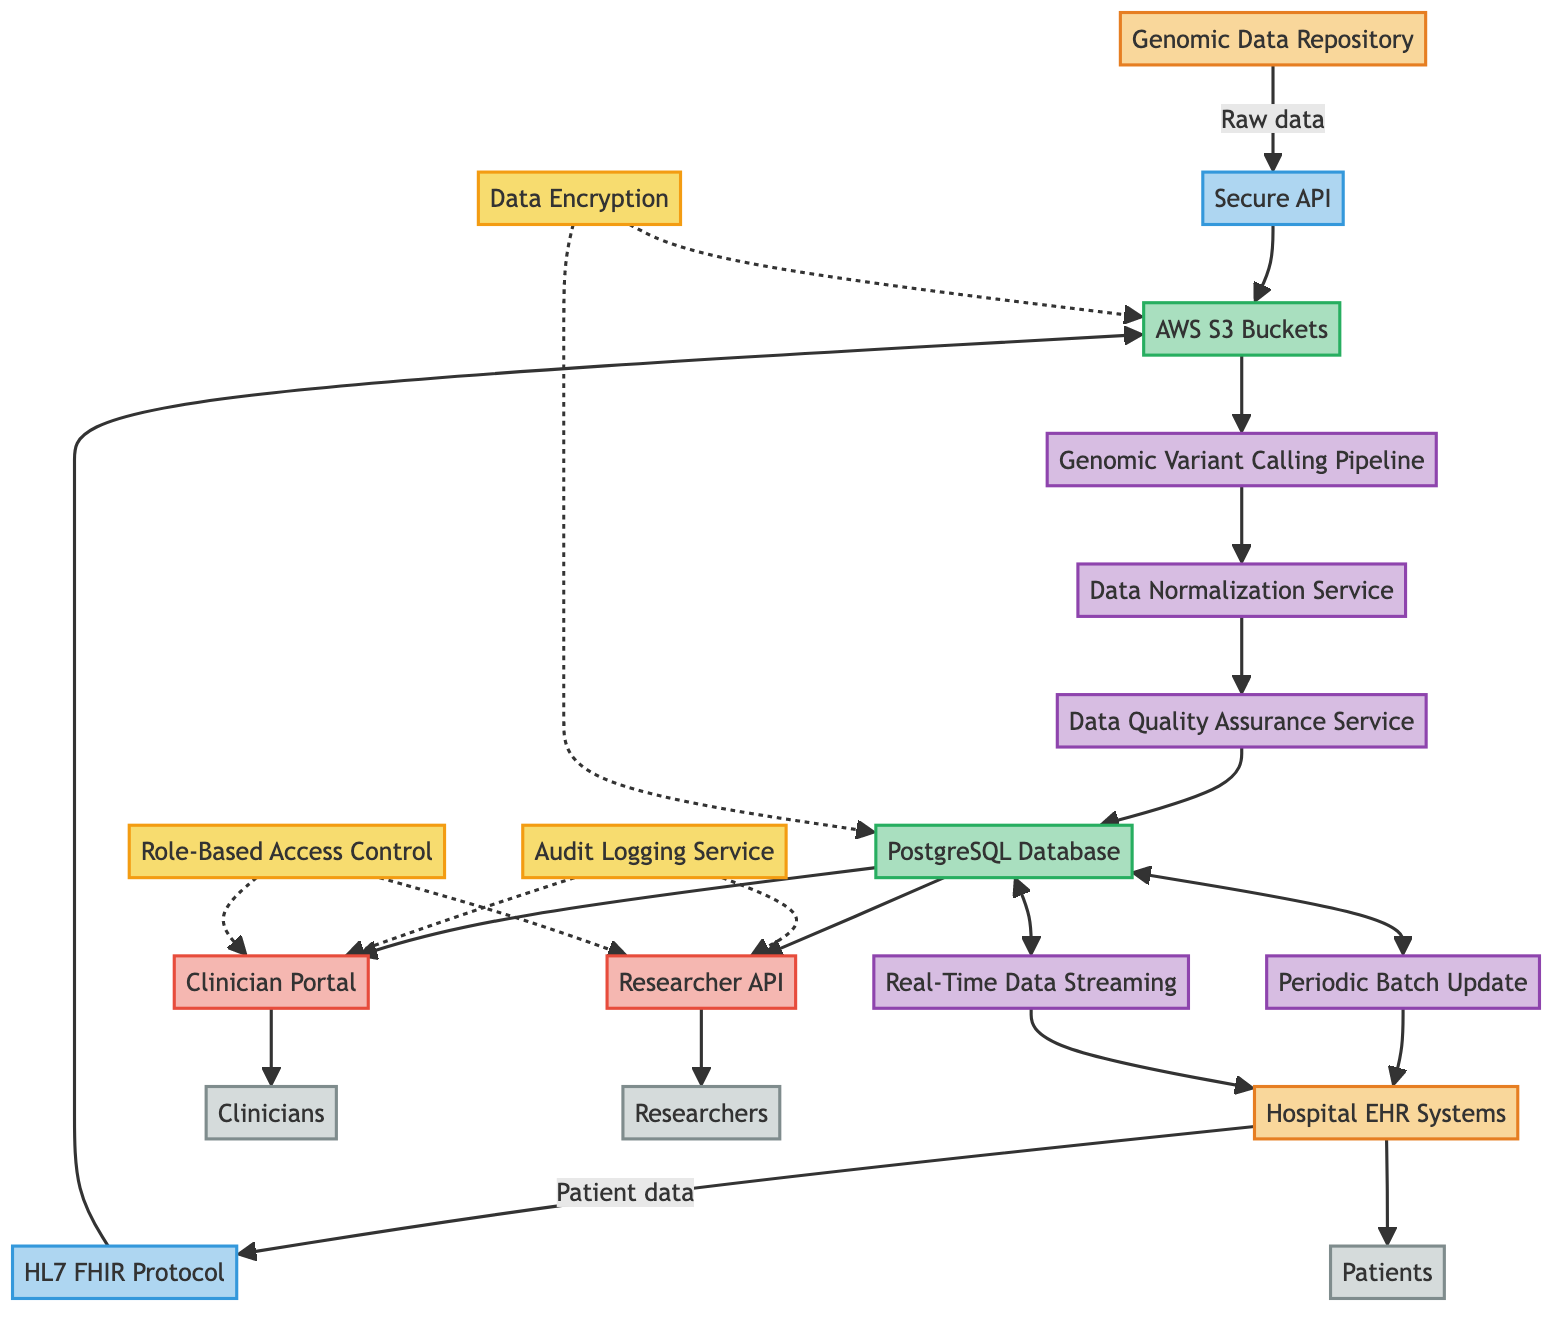What are the two data sources in the diagram? The two data sources are listed as "Genomic Data Repository" and "Hospital EHR Systems." These can be identified directly from the diagram as the starting points from where data originates.
Answer: Genomic Data Repository, Hospital EHR Systems What is the method used for data transfer from the genomic data repository? The method for data transfer from the genomic data repository is specified as "Secure API for Genomic Data Retrieval" in the diagram. This indicates how raw genomic data is transferred.
Answer: Secure API for Genomic Data Retrieval How many data synchronization mechanisms are shown in the diagram? The diagram displays two data synchronization mechanisms: "Periodic Batch Update" and "Real-Time Data Streaming." Counting them gives a total of two.
Answer: 2 Which component processes the genomic data before storing it in the PostgreSQL Database? The component that processes genomic data before storage is the "Data Quality Assurance Service," following the "Data Normalization Service" and "Genomic Variant Calling Pipeline." This flow indicates a sequential processing path before reaching storage.
Answer: Data Quality Assurance Service What type of access control is employed in the integration system? The type of access control employed is "Role-Based Access Control," which is indicated in the security section of the diagram, showing how access to data is managed based on user roles.
Answer: Role-Based Access Control How does the clinician access the data in the system? The clinician accesses data through the "Clinician Portal," which is a web-based interface specifically designed for clinicians, as shown in the user access interfaces section of the diagram.
Answer: Clinician Portal What is the role of the "Audit Logging Service"? The "Audit Logging Service" serves the role of "Data Access Monitoring," indicated in the security components of the diagram. This monitoring ensures that all data access is recorded for compliance and security purposes.
Answer: Data Access Monitoring Which users have access to the Researcher API? The users that have access to the Researcher API are "Genomics Researchers," as stated directly in the user access interfaces section of the diagram.
Answer: Genomics Researchers What type of data is stored in AWS S3 Buckets? The type of data stored in AWS S3 Buckets is classified as "Raw Data," indicated in the intermediate data storage section of the diagram, which shows where incoming data is initially held.
Answer: Raw Data 